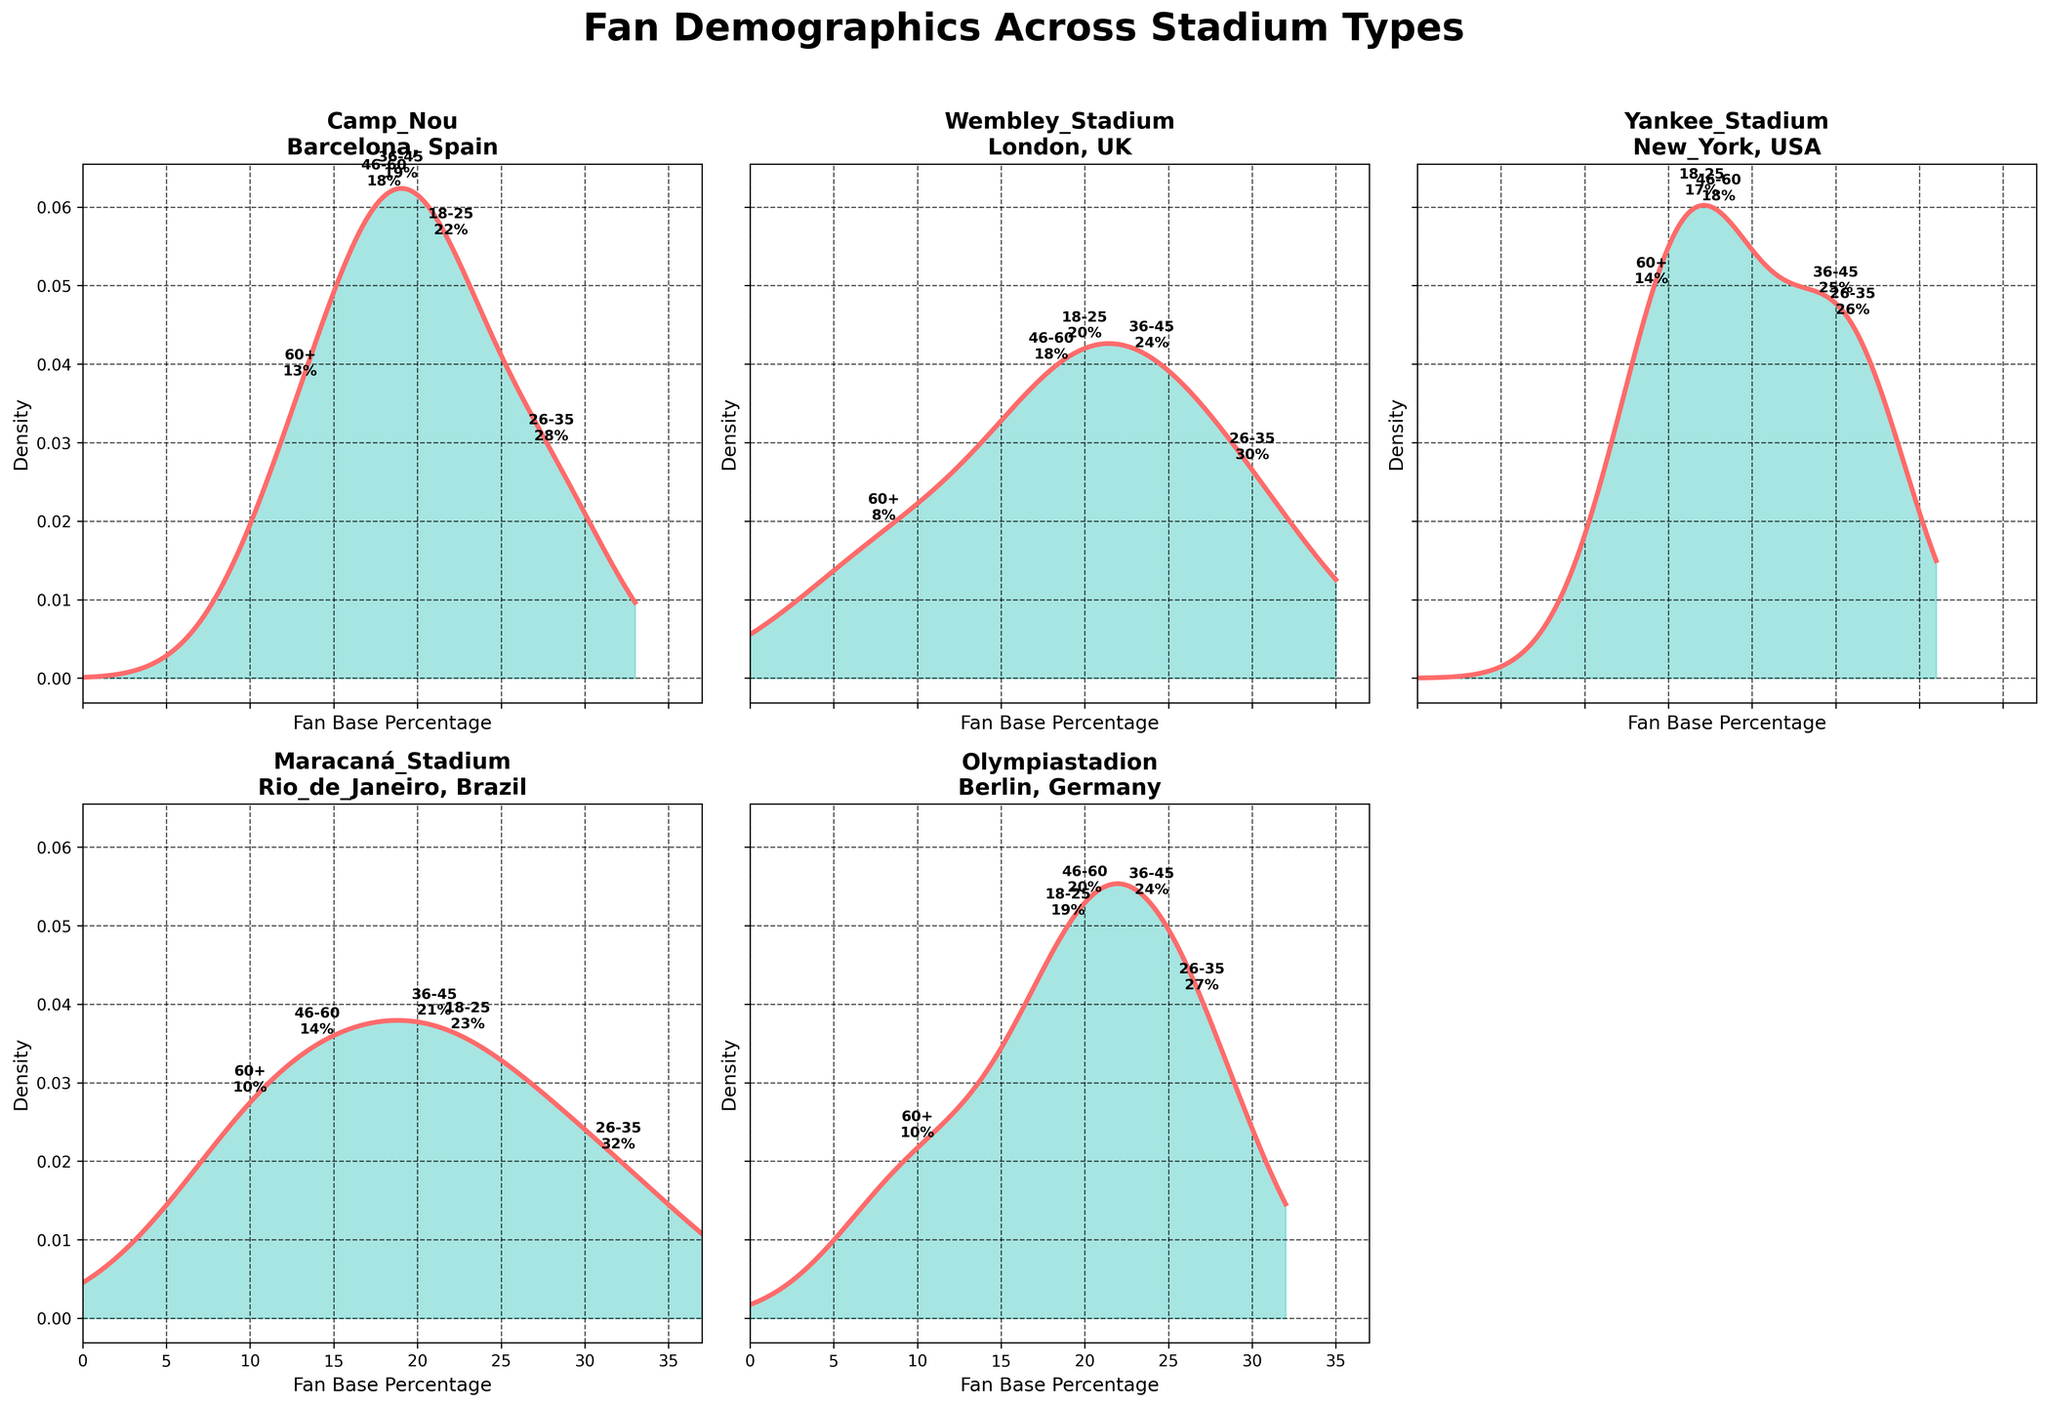What is the title of the figure? The title is positioned at the top center of the figure, and it reads "Fan Demographics Across Stadium Types"
Answer: Fan Demographics Across Stadium Types How many stadiums are covered in the figure? By counting the number of subplots, each representing a stadium, we see there are 5 stadiums.
Answer: 5 Which stadium has the highest percentage of fans in the 26-35 age group? Referring to the annotations in each subplot, the percentages for the 26-35 age group are: Camp Nou (28%), Wembley Stadium (30%), Yankee Stadium (26%), Maracaná Stadium (32%), Olympiastadion (27%). Maracaná Stadium has the highest percentage at 32%.
Answer: Maracaná Stadium Which stadium has the lowest density peak, and what does it indicate about the distribution of fan base percentages? By observing the height of the density peaks across all subplots, Wembley Stadium has the lowest density peak, indicating that the fan base percentages are more evenly spread out or less clustered around specific values compared to other stadiums.
Answer: Wembley Stadium What is the fan base percentage range covered in the density plots? The x-axis in each subplot shows the range of fan base percentages. The minimum value starts around 0, and the maximum value extends to just above 35%.
Answer: 0-35% Compare the density of fans aged 60+ between Olympiastadion and Yankee Stadium. By looking at the annotations and density curves for fans aged 60+, Olympiastadion has 10% and Yankee Stadium has 14%. The density at these percentages is both low for Olympiastadion and Yankee Stadium, indicating fewer fans in this age group in both stadiums but higher in Yankee Stadium.
Answer: Higher in Yankee Stadium Which two stadiums have the closest fan base distribution for the 36-45 age group? By comparing the annotations, the percentages for the 36-45 age group are: Camp Nou (19%), Wembley Stadium (24%), Yankee Stadium (25%), Maracaná Stadium (21%), Olympiastadion (24%). Wembley Stadium and Olympiastadion both have 24%.
Answer: Wembley Stadium and Olympiastadion What is the difference in the fan base percentage between the 18-25 and 60+ age groups at Camp Nou? Referring to the annotations for Camp Nou, the percentage for the 18-25 age group is 22%, and for the 60+ age group, it is 13%. The difference is 22% - 13% = 9%.
Answer: 9% Which age group has the most consistent fan base percentage across all stadiums? By examining the annotations, the 46-60 age group has percentages of 18% (Camp Nou), 18% (Wembley Stadium), 18% (Yankee Stadium), 14% (Maracaná Stadium), and 20% (Olympiastadion). The 46-60 age group is most consistent as the percentages do not vary as much as other age groups.
Answer: 46-60 Which city has the most fans in the 26-35 age group? By looking at the annotations, Maracaná Stadium in Rio de Janeiro, Brazil, has the highest percentage of fans in the 26-35 age group at 32%. Rio de Janeiro is the city.
Answer: Rio de Janeiro 